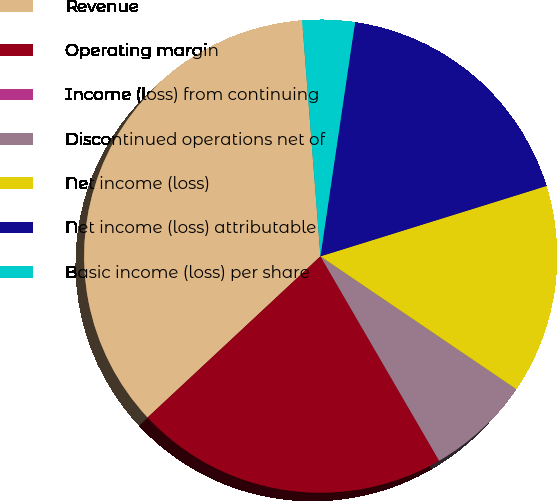Convert chart to OTSL. <chart><loc_0><loc_0><loc_500><loc_500><pie_chart><fcel>Revenue<fcel>Operating margin<fcel>Income (loss) from continuing<fcel>Discontinued operations net of<fcel>Net income (loss)<fcel>Net income (loss) attributable<fcel>Basic income (loss) per share<nl><fcel>35.71%<fcel>21.43%<fcel>0.0%<fcel>7.14%<fcel>14.29%<fcel>17.86%<fcel>3.57%<nl></chart> 